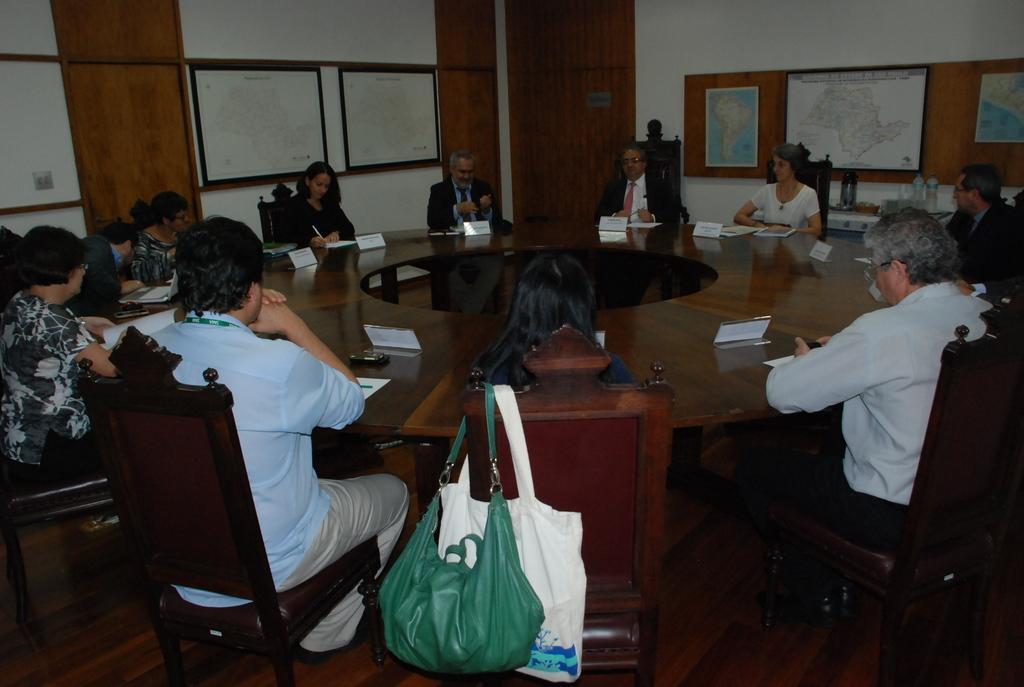In one or two sentences, can you explain what this image depicts? In this image I can see number of people are sitting on chairs, I can also see few of them are wearing suit and tie. Here I can see few bags and in the background I can see few maps. 